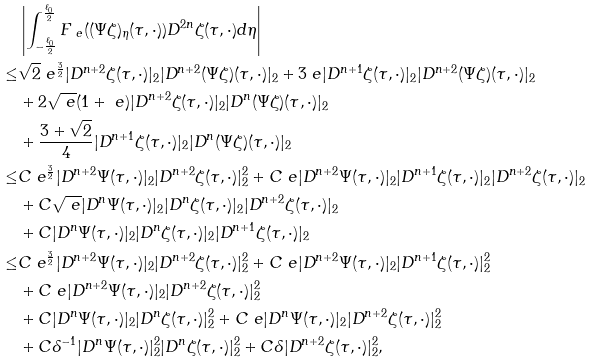Convert formula to latex. <formula><loc_0><loc_0><loc_500><loc_500>& \left | \int _ { - \frac { \ell _ { 0 } } { 2 } } ^ { \frac { \ell _ { 0 } } { 2 } } F _ { \ e } ( ( \Psi \zeta ) _ { \eta } ( \tau , \cdot ) ) D ^ { 2 n } \zeta ( \tau , \cdot ) d \eta \right | \\ \leq & \sqrt { 2 } \ e ^ { \frac { 3 } { 2 } } | D ^ { n + 2 } \zeta ( \tau , \cdot ) | _ { 2 } | D ^ { n + 2 } ( \Psi \zeta ) ( \tau , \cdot ) | _ { 2 } + 3 \ e | D ^ { n + 1 } \zeta ( \tau , \cdot ) | _ { 2 } | D ^ { n + 2 } ( \Psi \zeta ) ( \tau , \cdot ) | _ { 2 } \\ & + 2 \sqrt { \ e } ( 1 + \ e ) | D ^ { n + 2 } \zeta ( \tau , \cdot ) | _ { 2 } | D ^ { n } ( \Psi \zeta ) ( \tau , \cdot ) | _ { 2 } \\ & + \frac { 3 + \sqrt { 2 } } { 4 } | D ^ { n + 1 } \zeta ( \tau , \cdot ) | _ { 2 } | D ^ { n } ( \Psi \zeta ) ( \tau , \cdot ) | _ { 2 } \\ \leq & C \ e ^ { \frac { 3 } { 2 } } | D ^ { n + 2 } \Psi ( \tau , \cdot ) | _ { 2 } | D ^ { n + 2 } \zeta ( \tau , \cdot ) | _ { 2 } ^ { 2 } + C \ e | D ^ { n + 2 } \Psi ( \tau , \cdot ) | _ { 2 } | D ^ { n + 1 } \zeta ( \tau , \cdot ) | _ { 2 } | D ^ { n + 2 } \zeta ( \tau , \cdot ) | _ { 2 } \\ & + C \sqrt { \ e } | D ^ { n } \Psi ( \tau , \cdot ) | _ { 2 } | D ^ { n } \zeta ( \tau , \cdot ) | _ { 2 } | D ^ { n + 2 } \zeta ( \tau , \cdot ) | _ { 2 } \\ & + C | D ^ { n } \Psi ( \tau , \cdot ) | _ { 2 } | D ^ { n } \zeta ( \tau , \cdot ) | _ { 2 } | D ^ { n + 1 } \zeta ( \tau , \cdot ) | _ { 2 } \\ \leq & C \ e ^ { \frac { 3 } { 2 } } | D ^ { n + 2 } \Psi ( \tau , \cdot ) | _ { 2 } | D ^ { n + 2 } \zeta ( \tau , \cdot ) | _ { 2 } ^ { 2 } + C \ e | D ^ { n + 2 } \Psi ( \tau , \cdot ) | _ { 2 } | D ^ { n + 1 } \zeta ( \tau , \cdot ) | _ { 2 } ^ { 2 } \\ & + C \ e | D ^ { n + 2 } \Psi ( \tau , \cdot ) | _ { 2 } | D ^ { n + 2 } \zeta ( \tau , \cdot ) | _ { 2 } ^ { 2 } \\ & + C | D ^ { n } \Psi ( \tau , \cdot ) | _ { 2 } | D ^ { n } \zeta ( \tau , \cdot ) | _ { 2 } ^ { 2 } + C \ e | D ^ { n } \Psi ( \tau , \cdot ) | _ { 2 } | D ^ { n + 2 } \zeta ( \tau , \cdot ) | _ { 2 } ^ { 2 } \\ & + C \delta ^ { - 1 } | D ^ { n } \Psi ( \tau , \cdot ) | _ { 2 } ^ { 2 } | D ^ { n } \zeta ( \tau , \cdot ) | _ { 2 } ^ { 2 } + C \delta | D ^ { n + 2 } \zeta ( \tau , \cdot ) | _ { 2 } ^ { 2 } ,</formula> 